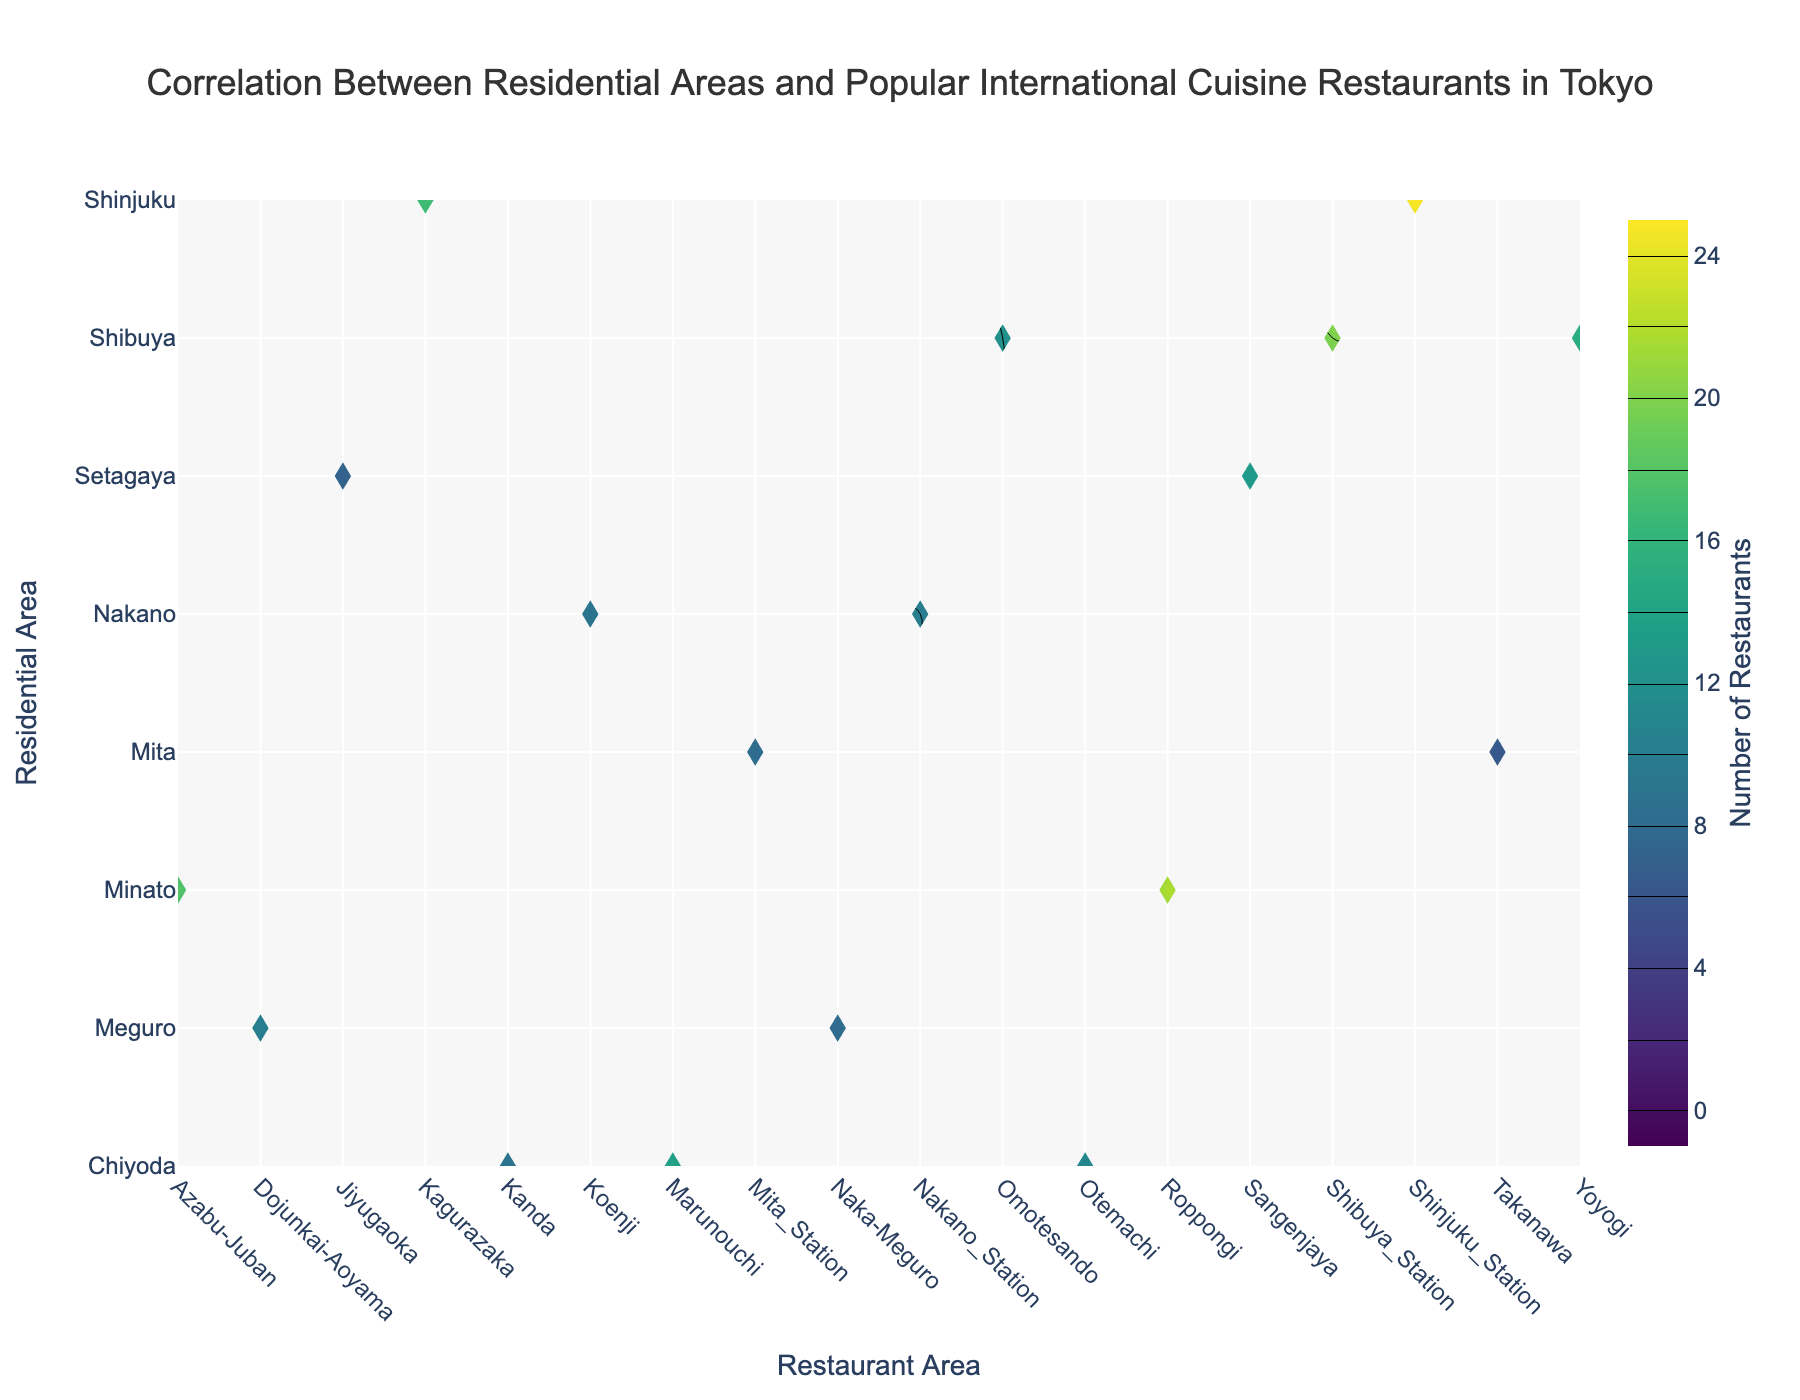What is the title of the figure? The title is displayed prominently at the top of the figure. It reads "Correlation Between Residential Areas and Popular International Cuisine Restaurants in Tokyo".
Answer: Correlation Between Residential Areas and Popular International Cuisine Restaurants in Tokyo What are the axes labels on the figure? The x-axis label reads "Restaurant Area", and the y-axis label reads "Residential Area". These labels are clearly marked on the respective axes.
Answer: Restaurant Area and Residential Area How many restaurant areas are represented on the x-axis? To determine the number of restaurant areas, count the distinct labels along the x-axis of the contour plot. They are Yoyogi, Omotesando, Shibuya_Station, Naka-Meguro, Dojunkai-Aoyama, Roppongi, Azabu-Juban, Marunouchi, Otemachi, Kanda, Sangenjaya, Jiyugaoka, Kagurazaka, Shinjuku_Station, Nakano_Station, Koenji, Mita_Station, and Takanawa.
Answer: 18 Which residential area has the largest number of popular international cuisine restaurants in Shibuya_Station? Locate Shibuya_Station on the x-axis and observe the color intensity and number on the contour plot. The contour with the darkest color and highest value indicates the residential area of Shibuya. Shibuya records the highest number of international cuisine restaurants at 20.
Answer: Shibuya What is the range of the color scale on the contour plot? The color scale ranges from a low to a high value. According to the color bar legend on the right side of the contour plot, the range starts at 0 and ends at 25.
Answer: 0 to 25 Which residential area has the smallest number of popular international cuisine restaurants in the dataset? Examine the contour plot and identify the residential areas with the lightest shading and smallest value. The residential area of Mita with Takanawa records the lowest value of 6.
Answer: Mita with Takanawa What is the average number of international cuisine restaurants for Setagaya across all restaurant areas? Locate the residential area of Setagaya on the y-axis and find the values across different restaurant areas. They are 13 for Sangenjaya and 7 for Jiyugaoka. The average is calculated as (13 + 7) / 2 = 10.
Answer: 10 Compare the number of international cuisine restaurants in Roppongi between Minato and Chiyoda. Which has more? Locate Roppongi on the x-axis and compare the values for Minato and Chiyoda. The number for Minato is 22, and for Chiyoda, it is absent as they don't correlate. Thus, Minato has visibly more.
Answer: Minato Which residential area has the greatest variation in the number of restaurants across different restaurant areas? To determine the greatest variation, identify the residential area with the widest range between the highest and lowest restaurant counts. Shibuya ranges from 12 in Omotesando to 20 in Shibuya_Station, showing an 8-point spread.
Answer: Shibuya Among the displayed restaurant areas, which one shows the highest count of popular international cuisine restaurants overall? By assessing the highest value displayed on the contour plot, Shinjuku_Station with a count of 25 under the Shinjuku residential area holds the maximum.
Answer: Shinjuku_Station 